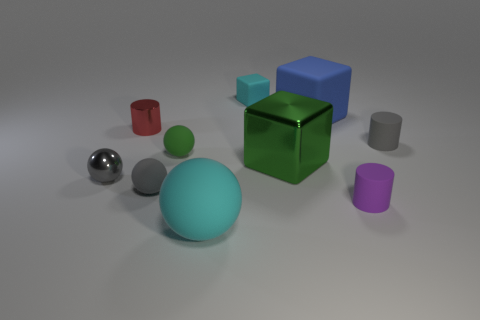Subtract all cylinders. How many objects are left? 7 Subtract all large matte cubes. Subtract all small purple cylinders. How many objects are left? 8 Add 4 big green metal cubes. How many big green metal cubes are left? 5 Add 6 big cyan matte blocks. How many big cyan matte blocks exist? 6 Subtract 0 yellow spheres. How many objects are left? 10 